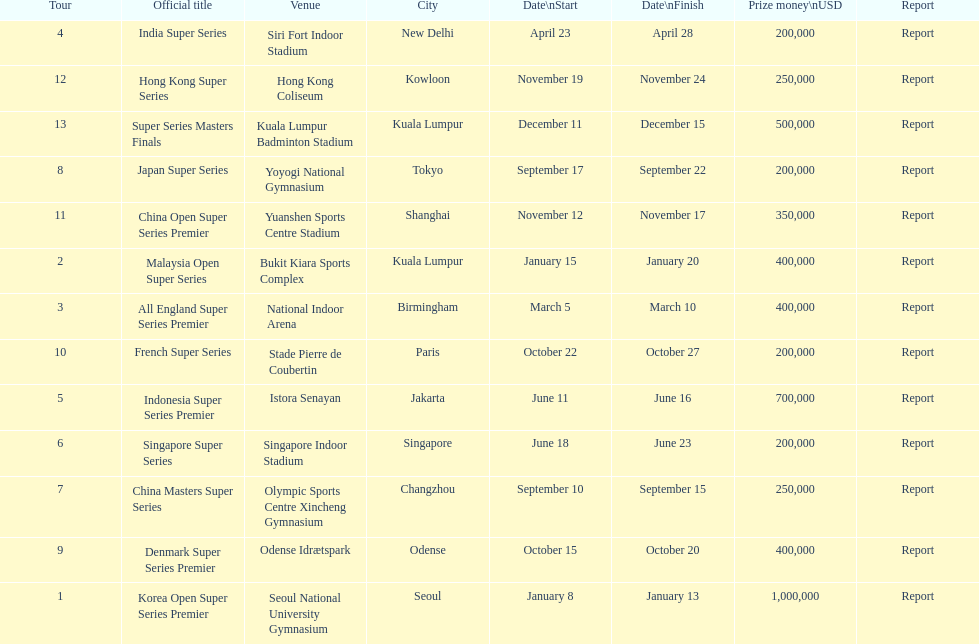How many happen in the final six months of the year? 7. 